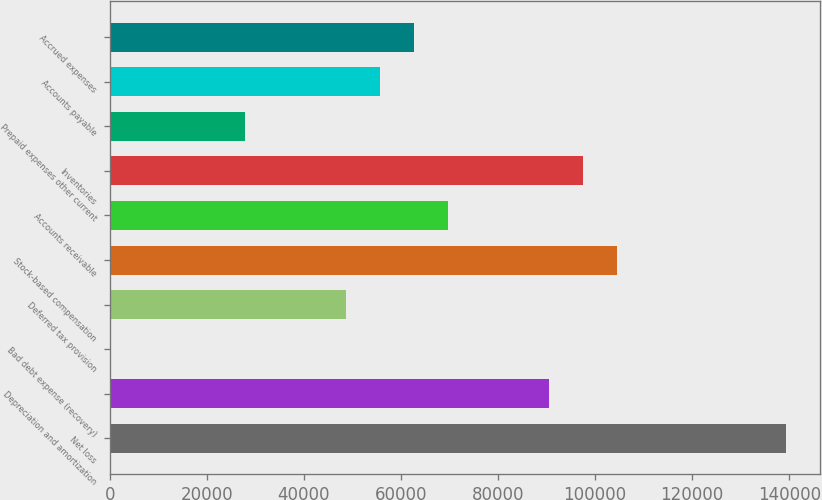Convert chart to OTSL. <chart><loc_0><loc_0><loc_500><loc_500><bar_chart><fcel>Net loss<fcel>Depreciation and amortization<fcel>Bad debt expense (recovery)<fcel>Deferred tax provision<fcel>Stock-based compensation<fcel>Accounts receivable<fcel>Inventories<fcel>Prepaid expenses other current<fcel>Accounts payable<fcel>Accrued expenses<nl><fcel>139285<fcel>90537.7<fcel>7<fcel>48754.3<fcel>104466<fcel>69646<fcel>97501.6<fcel>27862.6<fcel>55718.2<fcel>62682.1<nl></chart> 